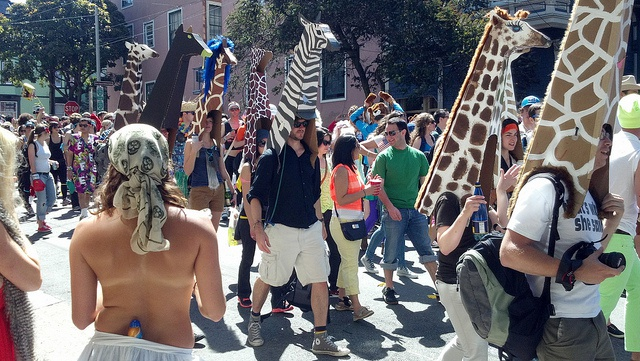Describe the objects in this image and their specific colors. I can see people in blue, black, darkgray, gray, and white tones, people in blue, brown, gray, and darkgray tones, people in blue, black, gray, darkgray, and lightgray tones, giraffe in blue, gray, darkgray, and lightgray tones, and people in blue, black, darkgray, and gray tones in this image. 